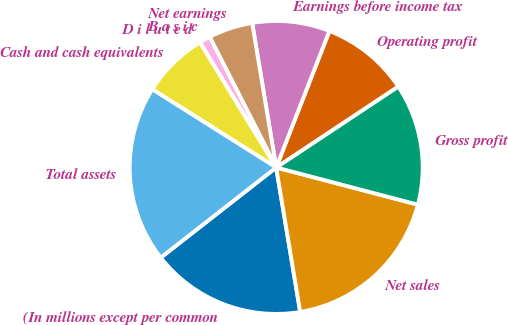Convert chart to OTSL. <chart><loc_0><loc_0><loc_500><loc_500><pie_chart><fcel>(In millions except per common<fcel>Net sales<fcel>Gross profit<fcel>Operating profit<fcel>Earnings before income tax<fcel>Net earnings<fcel>B a s i c<fcel>D i l u t e d<fcel>Cash and cash equivalents<fcel>Total assets<nl><fcel>17.07%<fcel>18.29%<fcel>13.41%<fcel>9.76%<fcel>8.54%<fcel>4.88%<fcel>1.22%<fcel>0.0%<fcel>7.32%<fcel>19.51%<nl></chart> 